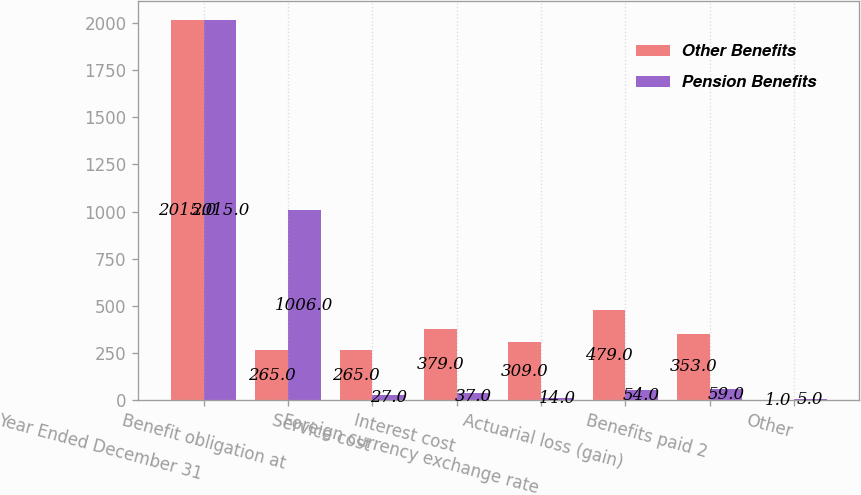Convert chart. <chart><loc_0><loc_0><loc_500><loc_500><stacked_bar_chart><ecel><fcel>Year Ended December 31<fcel>Benefit obligation at<fcel>Service cost<fcel>Interest cost<fcel>Foreign currency exchange rate<fcel>Actuarial loss (gain)<fcel>Benefits paid 2<fcel>Other<nl><fcel>Other Benefits<fcel>2015<fcel>265<fcel>265<fcel>379<fcel>309<fcel>479<fcel>353<fcel>1<nl><fcel>Pension Benefits<fcel>2015<fcel>1006<fcel>27<fcel>37<fcel>14<fcel>54<fcel>59<fcel>5<nl></chart> 